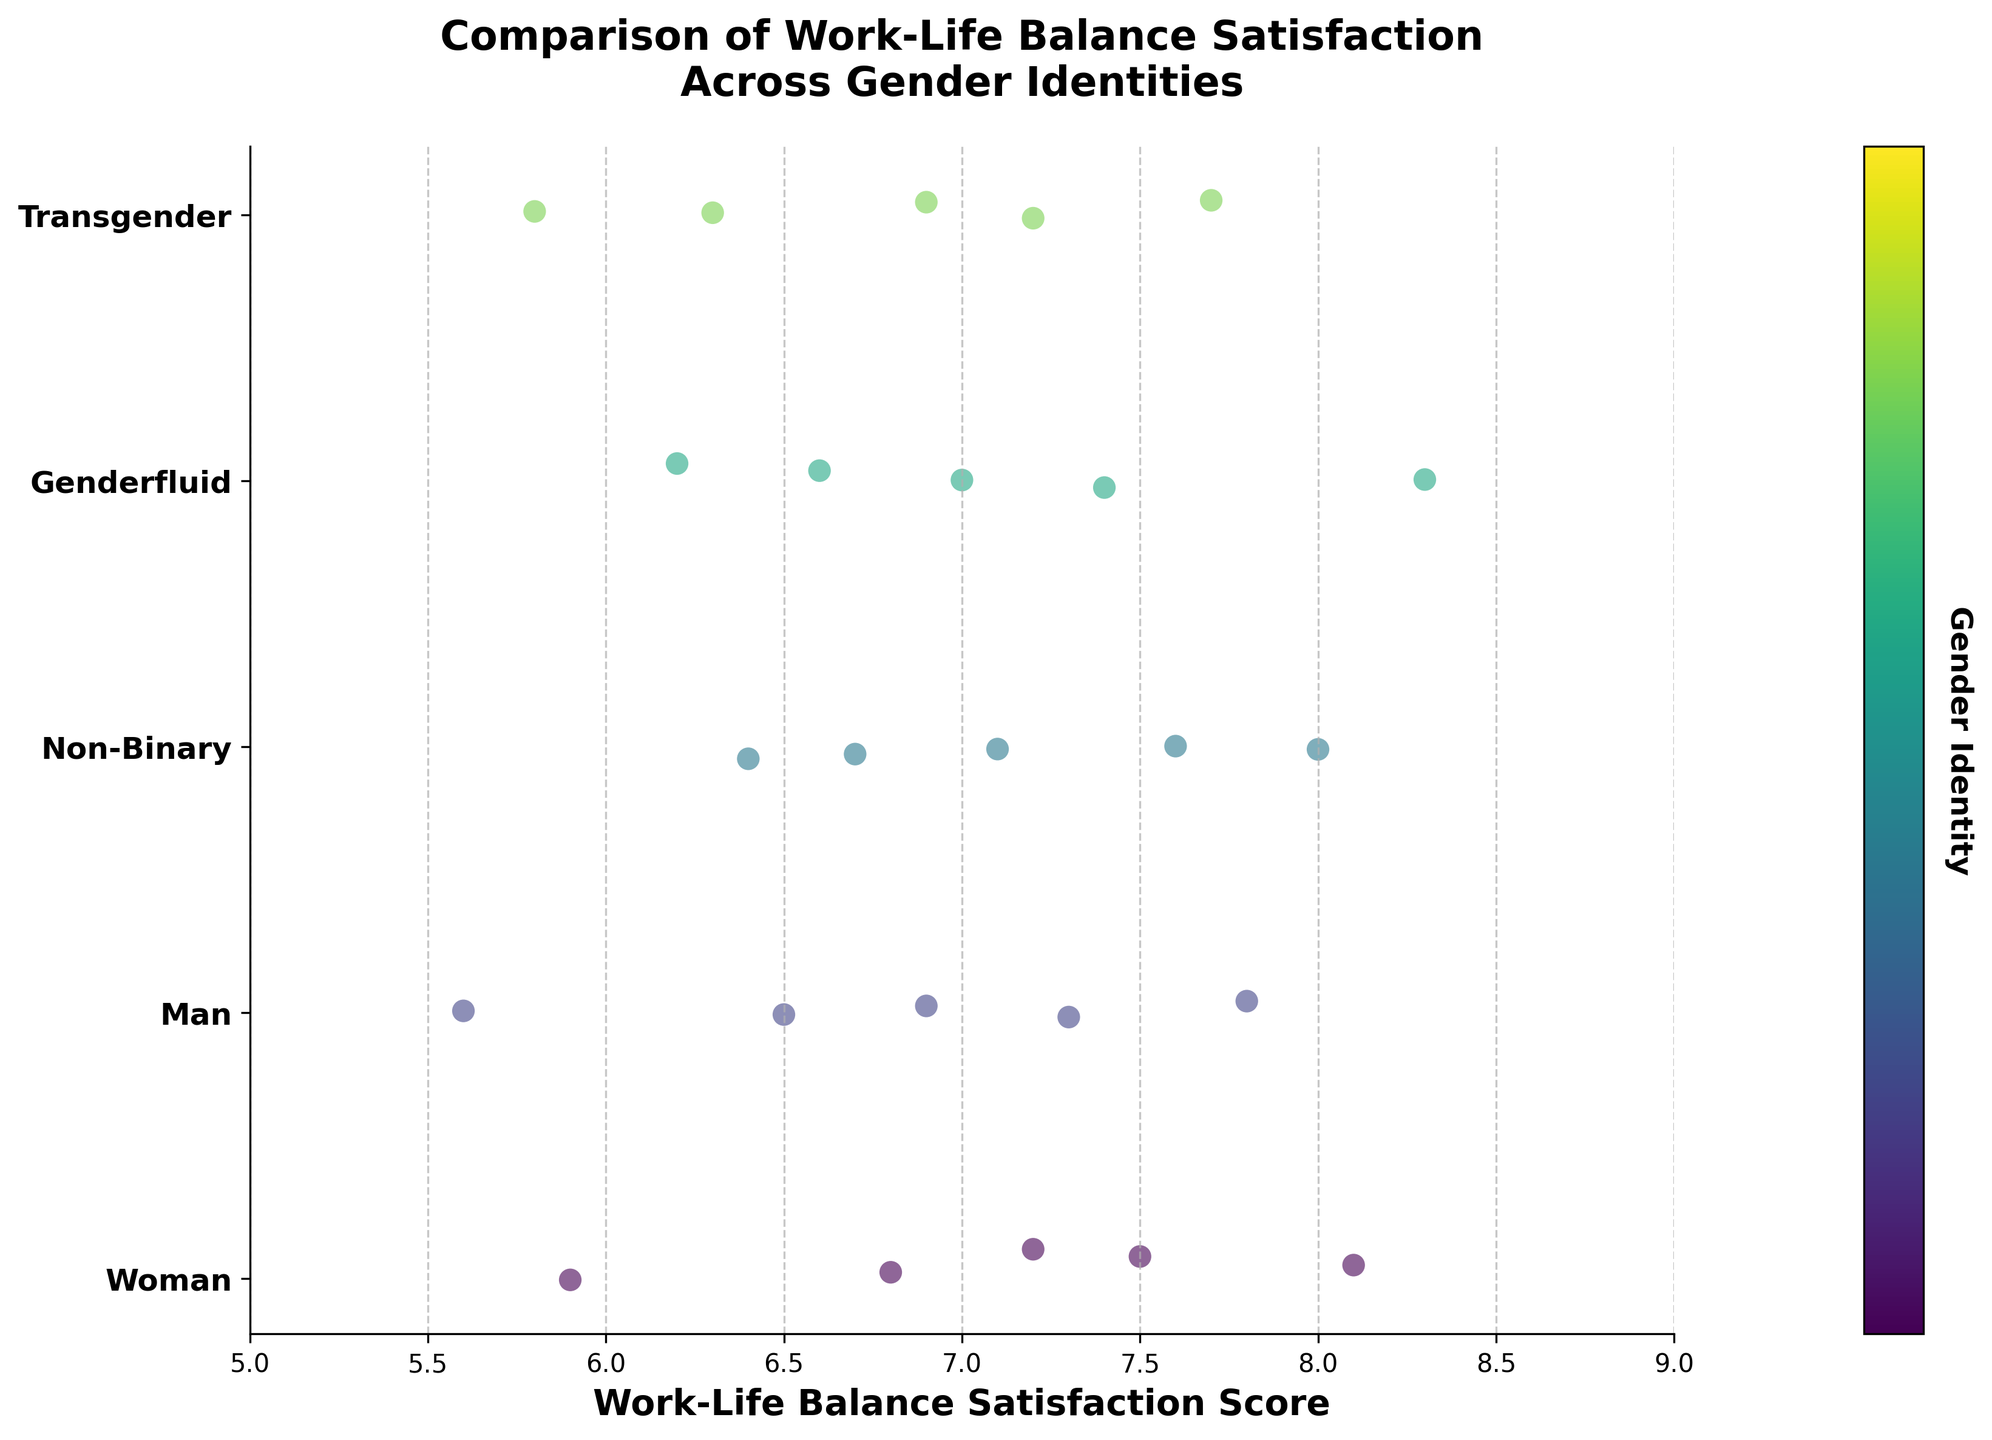What is the title of the strip plot? The title is located at the top center of the plot area. It reads: "Comparison of Work-Life Balance Satisfaction Across Gender Identities".
Answer: Comparison of Work-Life Balance Satisfaction Across Gender Identities What genders are compared in this strip plot? The y-axis labels represent different gender identities compared in the plot. They are Woman, Man, Non-Binary, Genderfluid, and Transgender.
Answer: Woman, Man, Non-Binary, Genderfluid, Transgender What is the Work-Life Balance Satisfaction Score range on the x-axis? The x-axis starts roughly around 5 and ends at 9. You can see this from the x-axis markers.
Answer: 5 to 9 Which group shows the highest work-life balance satisfaction? The highest point for Genderfluid can be identified at 8.3, which is higher than the maximum points of all other groups.
Answer: Genderfluid What's the average score for Transgender individuals? Add up the scores for Transgender (6.3, 7.7, 5.8, 7.2, 6.9) and divide by their number (5). (6.3 + 7.7 + 5.8 + 7.2 + 6.9) / 5 = 33.9 / 5 = 6.78
Answer: 6.78 How does the work-life balance satisfaction for Non-Binary individuals compare with that for Men? Look at the range and dispersion of the points: Non-Binary scores range from 6.4 to 8.0, Men range from 5.6 to 7.8. Non-Binary has a slightly higher maximum and minimum.
Answer: Non-Binary generally higher Which gender identity has the most spread in work-life balance satisfaction scores? Consider the range from the lowest to highest point for each group. Men range from 5.6 to 7.8 giving a spread of 2.2, which is larger than other groups.
Answer: Men Are there any gender identities with overlapping work-life balance satisfaction scores? If so, which? By examining the horizontal dispersion of the points overlap in groups. Woman and Man have overlapping scores in the range of 6.5 to 7.5.
Answer: Woman, Man Do any gender identities have identical median work-life balance satisfaction scores? To find the median, order each group's scores and find the middle value. Both Non-Binary and Genderfluid have median scores of 7.0.
Answer: Non-Binary, Genderfluid 